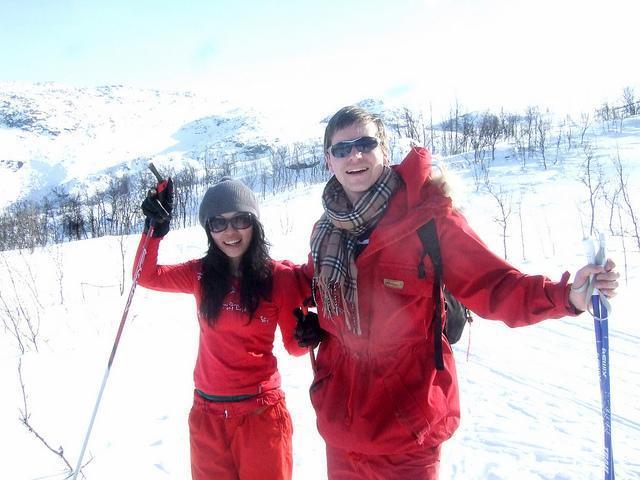How many people are there?
Give a very brief answer. 2. How many backpacks are there?
Give a very brief answer. 1. 